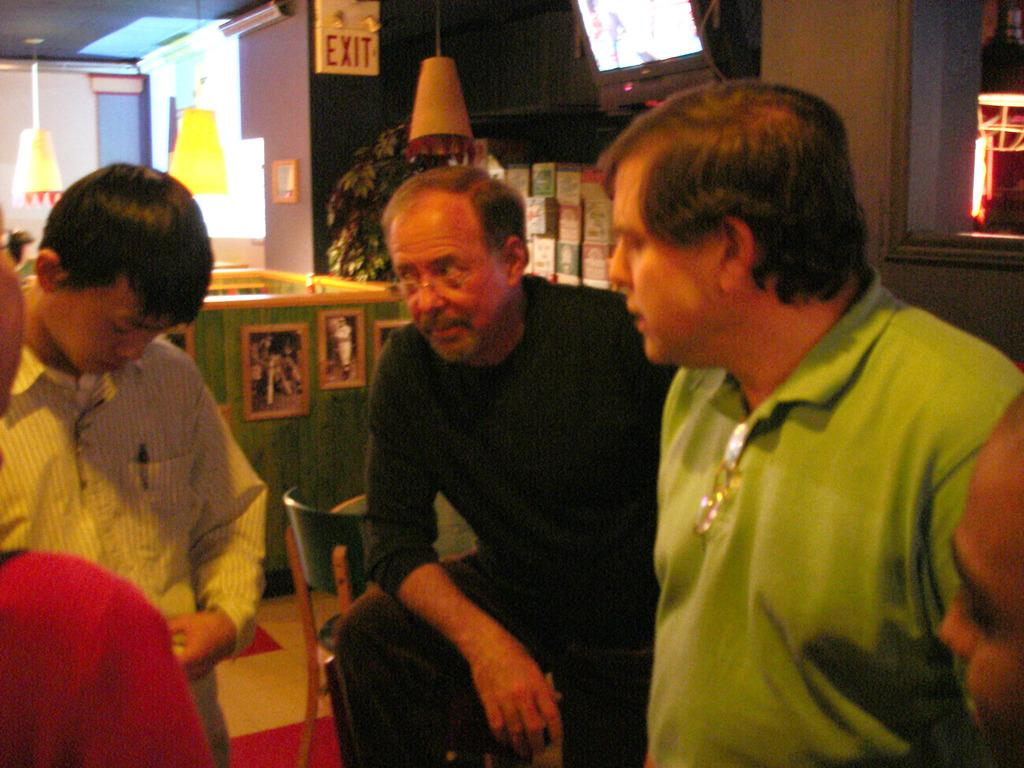How many people are present in the image? There are four people standing in the image. Where are the people standing? The people are standing on the floor. What other furniture is present in the image? There is a chair in the image. What can be seen on the wall in the image? There are frames on the wall. What is visible in the background of the image? There is a tree visible in the background of the image. How many dimes can be seen on the floor in the image? There are no dimes visible on the floor in the image. What type of grip does the tree in the background have? The image does not provide information about the grip of the tree in the background. 